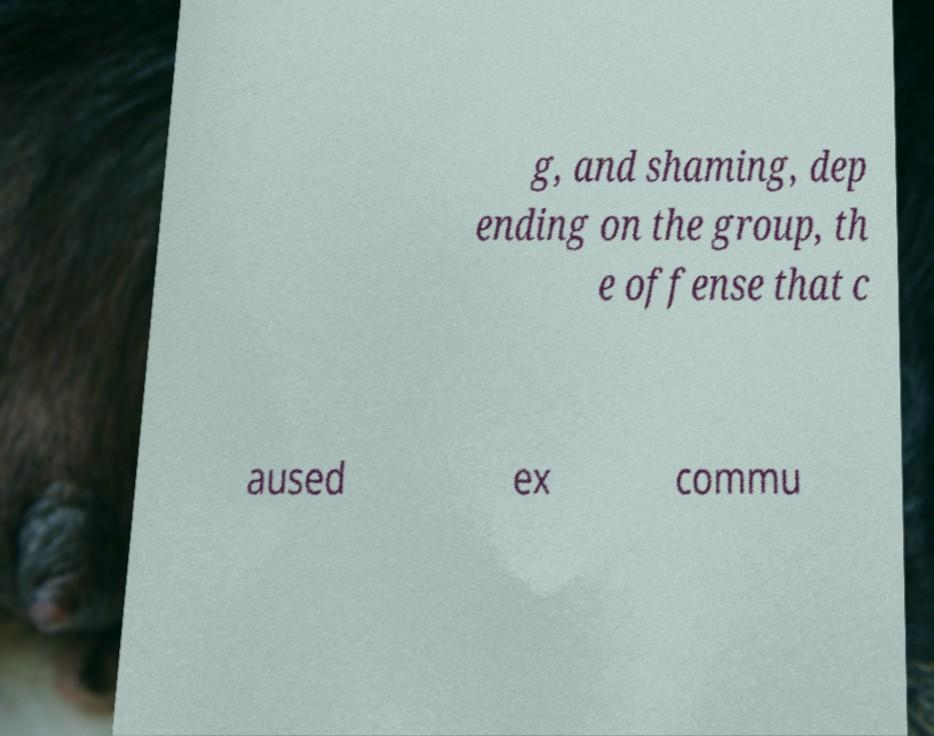I need the written content from this picture converted into text. Can you do that? g, and shaming, dep ending on the group, th e offense that c aused ex commu 